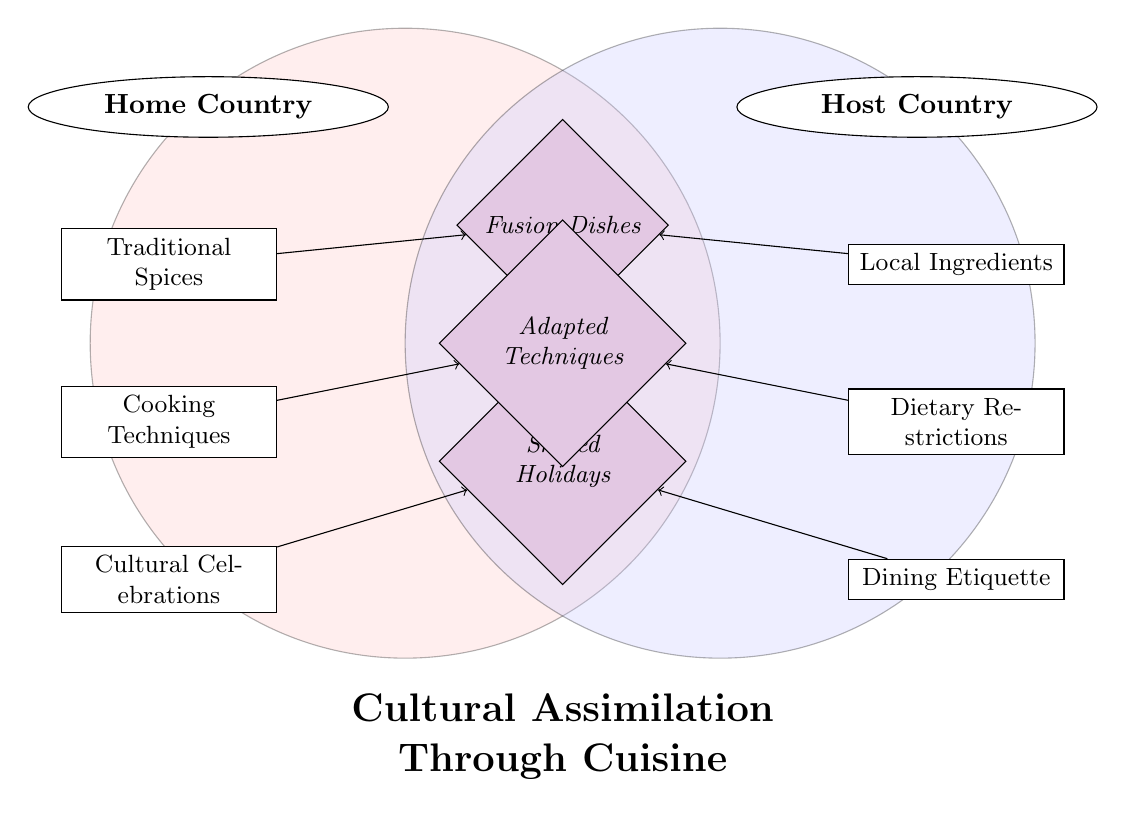What food practice from the Home Country represents traditional cooking methods? The node labeled "Cooking Techniques" is located in the Home Country category. It indicates practices that are traditional to the immigrant's home culture.
Answer: Cooking Techniques How many items are presented in the Host Country category? There are three items listed under the Host Country category: Local Ingredients, Dietary Restrictions, and Dining Etiquette. Counting these gives a total of three items.
Answer: 3 What connects Traditional Spices to Fusion Dishes? The diagram shows an arrow leading from the node labeled "Traditional Spices" in the Home Country to "Fusion Dishes" in the overlap. This indicates a direct relationship where traditional spices contribute to creating fusion dishes.
Answer: Fusion Dishes What is one item that represents a shared cultural event? The node "Shared Holidays" is located in the overlap section between the Home and Host Country, highlighting a common cultural celebration that transcends both food practices.
Answer: Shared Holidays Which item under Host Country involves restrictions related to food? The node labeled "Dietary Restrictions" in the Host Country category specifically deals with constraints on what can be consumed, implying cultural or health-related limitations.
Answer: Dietary Restrictions Which two items work together to form adapted cooking methods? The diagram shows "Cooking Techniques" from the Home Country and "Dietary Restrictions" from the Host Country both pointing towards the overlap labeled "Adapted Techniques," indicating that these factors influence the adaptation of cooking practices.
Answer: Adapted Techniques What type of dishes are formed when integrating home country spices and local ingredients? The overlap labeled "Fusion Dishes" combines elements from both the Home Country (spices) and the Host Country (local ingredients), demonstrating how special dishes are created from merging diverse culinary traditions.
Answer: Fusion Dishes What is the visual representation used in this diagram? The diagram uniquely displays a Venn Diagram structure, illustrating overlapping cultural elements between the Home and Host Country through various food practices and their connections.
Answer: Venn Diagram 